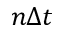Convert formula to latex. <formula><loc_0><loc_0><loc_500><loc_500>n \Delta t</formula> 